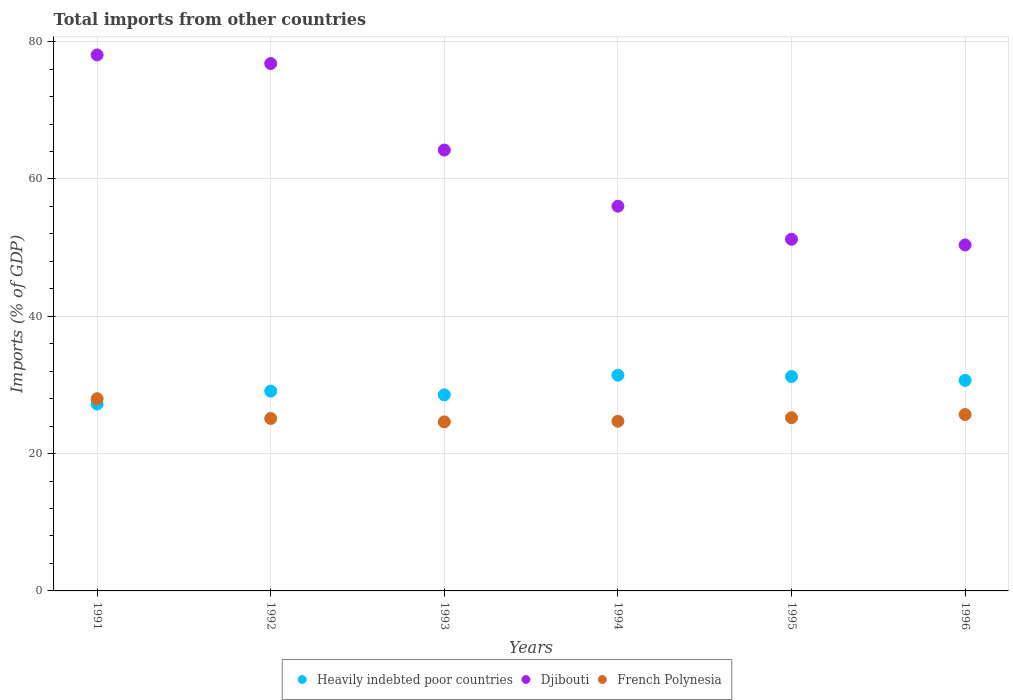Is the number of dotlines equal to the number of legend labels?
Provide a succinct answer. Yes. What is the total imports in French Polynesia in 1994?
Your answer should be compact. 24.71. Across all years, what is the maximum total imports in French Polynesia?
Your answer should be compact. 27.99. Across all years, what is the minimum total imports in Heavily indebted poor countries?
Your response must be concise. 27.21. In which year was the total imports in Heavily indebted poor countries maximum?
Your answer should be compact. 1994. In which year was the total imports in Djibouti minimum?
Your answer should be compact. 1996. What is the total total imports in Djibouti in the graph?
Your response must be concise. 376.7. What is the difference between the total imports in Heavily indebted poor countries in 1991 and that in 1993?
Offer a terse response. -1.34. What is the difference between the total imports in French Polynesia in 1991 and the total imports in Djibouti in 1996?
Your answer should be compact. -22.39. What is the average total imports in French Polynesia per year?
Make the answer very short. 25.56. In the year 1993, what is the difference between the total imports in Djibouti and total imports in French Polynesia?
Your answer should be compact. 39.59. What is the ratio of the total imports in French Polynesia in 1992 to that in 1994?
Make the answer very short. 1.02. Is the total imports in Djibouti in 1994 less than that in 1995?
Give a very brief answer. No. Is the difference between the total imports in Djibouti in 1994 and 1995 greater than the difference between the total imports in French Polynesia in 1994 and 1995?
Keep it short and to the point. Yes. What is the difference between the highest and the second highest total imports in Djibouti?
Provide a succinct answer. 1.26. What is the difference between the highest and the lowest total imports in Djibouti?
Your response must be concise. 27.68. In how many years, is the total imports in Djibouti greater than the average total imports in Djibouti taken over all years?
Offer a terse response. 3. Does the total imports in Djibouti monotonically increase over the years?
Offer a terse response. No. Is the total imports in Heavily indebted poor countries strictly greater than the total imports in Djibouti over the years?
Provide a succinct answer. No. How many years are there in the graph?
Provide a short and direct response. 6. Are the values on the major ticks of Y-axis written in scientific E-notation?
Keep it short and to the point. No. Does the graph contain grids?
Your answer should be very brief. Yes. Where does the legend appear in the graph?
Make the answer very short. Bottom center. What is the title of the graph?
Offer a very short reply. Total imports from other countries. Does "Northern Mariana Islands" appear as one of the legend labels in the graph?
Provide a succinct answer. No. What is the label or title of the X-axis?
Keep it short and to the point. Years. What is the label or title of the Y-axis?
Give a very brief answer. Imports (% of GDP). What is the Imports (% of GDP) of Heavily indebted poor countries in 1991?
Your answer should be compact. 27.21. What is the Imports (% of GDP) of Djibouti in 1991?
Provide a short and direct response. 78.06. What is the Imports (% of GDP) in French Polynesia in 1991?
Ensure brevity in your answer.  27.99. What is the Imports (% of GDP) in Heavily indebted poor countries in 1992?
Keep it short and to the point. 29.1. What is the Imports (% of GDP) of Djibouti in 1992?
Ensure brevity in your answer.  76.8. What is the Imports (% of GDP) of French Polynesia in 1992?
Make the answer very short. 25.12. What is the Imports (% of GDP) in Heavily indebted poor countries in 1993?
Give a very brief answer. 28.55. What is the Imports (% of GDP) in Djibouti in 1993?
Keep it short and to the point. 64.21. What is the Imports (% of GDP) of French Polynesia in 1993?
Make the answer very short. 24.62. What is the Imports (% of GDP) in Heavily indebted poor countries in 1994?
Provide a succinct answer. 31.42. What is the Imports (% of GDP) in Djibouti in 1994?
Provide a short and direct response. 56.03. What is the Imports (% of GDP) of French Polynesia in 1994?
Ensure brevity in your answer.  24.71. What is the Imports (% of GDP) in Heavily indebted poor countries in 1995?
Your answer should be very brief. 31.22. What is the Imports (% of GDP) in Djibouti in 1995?
Provide a short and direct response. 51.22. What is the Imports (% of GDP) in French Polynesia in 1995?
Your response must be concise. 25.23. What is the Imports (% of GDP) in Heavily indebted poor countries in 1996?
Provide a succinct answer. 30.67. What is the Imports (% of GDP) of Djibouti in 1996?
Offer a very short reply. 50.39. What is the Imports (% of GDP) of French Polynesia in 1996?
Your response must be concise. 25.69. Across all years, what is the maximum Imports (% of GDP) in Heavily indebted poor countries?
Provide a short and direct response. 31.42. Across all years, what is the maximum Imports (% of GDP) in Djibouti?
Ensure brevity in your answer.  78.06. Across all years, what is the maximum Imports (% of GDP) in French Polynesia?
Provide a short and direct response. 27.99. Across all years, what is the minimum Imports (% of GDP) of Heavily indebted poor countries?
Make the answer very short. 27.21. Across all years, what is the minimum Imports (% of GDP) of Djibouti?
Provide a succinct answer. 50.39. Across all years, what is the minimum Imports (% of GDP) in French Polynesia?
Your response must be concise. 24.62. What is the total Imports (% of GDP) of Heavily indebted poor countries in the graph?
Your answer should be compact. 178.17. What is the total Imports (% of GDP) of Djibouti in the graph?
Your answer should be compact. 376.7. What is the total Imports (% of GDP) in French Polynesia in the graph?
Offer a very short reply. 153.35. What is the difference between the Imports (% of GDP) of Heavily indebted poor countries in 1991 and that in 1992?
Give a very brief answer. -1.89. What is the difference between the Imports (% of GDP) in Djibouti in 1991 and that in 1992?
Your answer should be very brief. 1.26. What is the difference between the Imports (% of GDP) of French Polynesia in 1991 and that in 1992?
Provide a succinct answer. 2.88. What is the difference between the Imports (% of GDP) in Heavily indebted poor countries in 1991 and that in 1993?
Ensure brevity in your answer.  -1.34. What is the difference between the Imports (% of GDP) in Djibouti in 1991 and that in 1993?
Provide a short and direct response. 13.85. What is the difference between the Imports (% of GDP) of French Polynesia in 1991 and that in 1993?
Provide a succinct answer. 3.37. What is the difference between the Imports (% of GDP) of Heavily indebted poor countries in 1991 and that in 1994?
Provide a short and direct response. -4.21. What is the difference between the Imports (% of GDP) of Djibouti in 1991 and that in 1994?
Your response must be concise. 22.03. What is the difference between the Imports (% of GDP) in French Polynesia in 1991 and that in 1994?
Make the answer very short. 3.28. What is the difference between the Imports (% of GDP) of Heavily indebted poor countries in 1991 and that in 1995?
Offer a terse response. -4.01. What is the difference between the Imports (% of GDP) of Djibouti in 1991 and that in 1995?
Your answer should be very brief. 26.84. What is the difference between the Imports (% of GDP) of French Polynesia in 1991 and that in 1995?
Offer a very short reply. 2.77. What is the difference between the Imports (% of GDP) in Heavily indebted poor countries in 1991 and that in 1996?
Offer a terse response. -3.45. What is the difference between the Imports (% of GDP) in Djibouti in 1991 and that in 1996?
Ensure brevity in your answer.  27.68. What is the difference between the Imports (% of GDP) of French Polynesia in 1991 and that in 1996?
Provide a succinct answer. 2.31. What is the difference between the Imports (% of GDP) in Heavily indebted poor countries in 1992 and that in 1993?
Your answer should be very brief. 0.54. What is the difference between the Imports (% of GDP) in Djibouti in 1992 and that in 1993?
Your answer should be very brief. 12.59. What is the difference between the Imports (% of GDP) in French Polynesia in 1992 and that in 1993?
Make the answer very short. 0.5. What is the difference between the Imports (% of GDP) of Heavily indebted poor countries in 1992 and that in 1994?
Make the answer very short. -2.32. What is the difference between the Imports (% of GDP) in Djibouti in 1992 and that in 1994?
Your answer should be very brief. 20.77. What is the difference between the Imports (% of GDP) of French Polynesia in 1992 and that in 1994?
Ensure brevity in your answer.  0.4. What is the difference between the Imports (% of GDP) of Heavily indebted poor countries in 1992 and that in 1995?
Make the answer very short. -2.12. What is the difference between the Imports (% of GDP) of Djibouti in 1992 and that in 1995?
Offer a very short reply. 25.58. What is the difference between the Imports (% of GDP) in French Polynesia in 1992 and that in 1995?
Your answer should be very brief. -0.11. What is the difference between the Imports (% of GDP) of Heavily indebted poor countries in 1992 and that in 1996?
Your response must be concise. -1.57. What is the difference between the Imports (% of GDP) in Djibouti in 1992 and that in 1996?
Make the answer very short. 26.42. What is the difference between the Imports (% of GDP) in French Polynesia in 1992 and that in 1996?
Give a very brief answer. -0.57. What is the difference between the Imports (% of GDP) of Heavily indebted poor countries in 1993 and that in 1994?
Provide a succinct answer. -2.86. What is the difference between the Imports (% of GDP) in Djibouti in 1993 and that in 1994?
Make the answer very short. 8.18. What is the difference between the Imports (% of GDP) of French Polynesia in 1993 and that in 1994?
Provide a short and direct response. -0.09. What is the difference between the Imports (% of GDP) in Heavily indebted poor countries in 1993 and that in 1995?
Your answer should be very brief. -2.67. What is the difference between the Imports (% of GDP) of Djibouti in 1993 and that in 1995?
Your response must be concise. 12.99. What is the difference between the Imports (% of GDP) of French Polynesia in 1993 and that in 1995?
Offer a terse response. -0.61. What is the difference between the Imports (% of GDP) of Heavily indebted poor countries in 1993 and that in 1996?
Ensure brevity in your answer.  -2.11. What is the difference between the Imports (% of GDP) in Djibouti in 1993 and that in 1996?
Offer a very short reply. 13.82. What is the difference between the Imports (% of GDP) in French Polynesia in 1993 and that in 1996?
Offer a terse response. -1.07. What is the difference between the Imports (% of GDP) in Heavily indebted poor countries in 1994 and that in 1995?
Provide a succinct answer. 0.2. What is the difference between the Imports (% of GDP) of Djibouti in 1994 and that in 1995?
Ensure brevity in your answer.  4.81. What is the difference between the Imports (% of GDP) in French Polynesia in 1994 and that in 1995?
Your answer should be very brief. -0.51. What is the difference between the Imports (% of GDP) of Heavily indebted poor countries in 1994 and that in 1996?
Provide a short and direct response. 0.75. What is the difference between the Imports (% of GDP) in Djibouti in 1994 and that in 1996?
Your response must be concise. 5.64. What is the difference between the Imports (% of GDP) of French Polynesia in 1994 and that in 1996?
Give a very brief answer. -0.97. What is the difference between the Imports (% of GDP) in Heavily indebted poor countries in 1995 and that in 1996?
Offer a terse response. 0.56. What is the difference between the Imports (% of GDP) in Djibouti in 1995 and that in 1996?
Give a very brief answer. 0.83. What is the difference between the Imports (% of GDP) in French Polynesia in 1995 and that in 1996?
Offer a terse response. -0.46. What is the difference between the Imports (% of GDP) of Heavily indebted poor countries in 1991 and the Imports (% of GDP) of Djibouti in 1992?
Ensure brevity in your answer.  -49.59. What is the difference between the Imports (% of GDP) in Heavily indebted poor countries in 1991 and the Imports (% of GDP) in French Polynesia in 1992?
Offer a terse response. 2.1. What is the difference between the Imports (% of GDP) in Djibouti in 1991 and the Imports (% of GDP) in French Polynesia in 1992?
Your answer should be compact. 52.94. What is the difference between the Imports (% of GDP) in Heavily indebted poor countries in 1991 and the Imports (% of GDP) in Djibouti in 1993?
Make the answer very short. -36.99. What is the difference between the Imports (% of GDP) in Heavily indebted poor countries in 1991 and the Imports (% of GDP) in French Polynesia in 1993?
Offer a terse response. 2.59. What is the difference between the Imports (% of GDP) in Djibouti in 1991 and the Imports (% of GDP) in French Polynesia in 1993?
Offer a terse response. 53.44. What is the difference between the Imports (% of GDP) of Heavily indebted poor countries in 1991 and the Imports (% of GDP) of Djibouti in 1994?
Make the answer very short. -28.82. What is the difference between the Imports (% of GDP) of Heavily indebted poor countries in 1991 and the Imports (% of GDP) of French Polynesia in 1994?
Offer a very short reply. 2.5. What is the difference between the Imports (% of GDP) of Djibouti in 1991 and the Imports (% of GDP) of French Polynesia in 1994?
Your answer should be compact. 53.35. What is the difference between the Imports (% of GDP) in Heavily indebted poor countries in 1991 and the Imports (% of GDP) in Djibouti in 1995?
Your response must be concise. -24. What is the difference between the Imports (% of GDP) of Heavily indebted poor countries in 1991 and the Imports (% of GDP) of French Polynesia in 1995?
Provide a short and direct response. 1.99. What is the difference between the Imports (% of GDP) of Djibouti in 1991 and the Imports (% of GDP) of French Polynesia in 1995?
Offer a terse response. 52.83. What is the difference between the Imports (% of GDP) of Heavily indebted poor countries in 1991 and the Imports (% of GDP) of Djibouti in 1996?
Your answer should be compact. -23.17. What is the difference between the Imports (% of GDP) in Heavily indebted poor countries in 1991 and the Imports (% of GDP) in French Polynesia in 1996?
Keep it short and to the point. 1.53. What is the difference between the Imports (% of GDP) of Djibouti in 1991 and the Imports (% of GDP) of French Polynesia in 1996?
Provide a short and direct response. 52.37. What is the difference between the Imports (% of GDP) in Heavily indebted poor countries in 1992 and the Imports (% of GDP) in Djibouti in 1993?
Your response must be concise. -35.11. What is the difference between the Imports (% of GDP) in Heavily indebted poor countries in 1992 and the Imports (% of GDP) in French Polynesia in 1993?
Your answer should be very brief. 4.48. What is the difference between the Imports (% of GDP) of Djibouti in 1992 and the Imports (% of GDP) of French Polynesia in 1993?
Keep it short and to the point. 52.18. What is the difference between the Imports (% of GDP) of Heavily indebted poor countries in 1992 and the Imports (% of GDP) of Djibouti in 1994?
Your response must be concise. -26.93. What is the difference between the Imports (% of GDP) of Heavily indebted poor countries in 1992 and the Imports (% of GDP) of French Polynesia in 1994?
Offer a terse response. 4.39. What is the difference between the Imports (% of GDP) of Djibouti in 1992 and the Imports (% of GDP) of French Polynesia in 1994?
Ensure brevity in your answer.  52.09. What is the difference between the Imports (% of GDP) of Heavily indebted poor countries in 1992 and the Imports (% of GDP) of Djibouti in 1995?
Make the answer very short. -22.12. What is the difference between the Imports (% of GDP) in Heavily indebted poor countries in 1992 and the Imports (% of GDP) in French Polynesia in 1995?
Your answer should be compact. 3.87. What is the difference between the Imports (% of GDP) of Djibouti in 1992 and the Imports (% of GDP) of French Polynesia in 1995?
Your response must be concise. 51.58. What is the difference between the Imports (% of GDP) of Heavily indebted poor countries in 1992 and the Imports (% of GDP) of Djibouti in 1996?
Your answer should be compact. -21.29. What is the difference between the Imports (% of GDP) of Heavily indebted poor countries in 1992 and the Imports (% of GDP) of French Polynesia in 1996?
Provide a succinct answer. 3.41. What is the difference between the Imports (% of GDP) in Djibouti in 1992 and the Imports (% of GDP) in French Polynesia in 1996?
Ensure brevity in your answer.  51.12. What is the difference between the Imports (% of GDP) of Heavily indebted poor countries in 1993 and the Imports (% of GDP) of Djibouti in 1994?
Offer a very short reply. -27.48. What is the difference between the Imports (% of GDP) in Heavily indebted poor countries in 1993 and the Imports (% of GDP) in French Polynesia in 1994?
Your answer should be compact. 3.84. What is the difference between the Imports (% of GDP) in Djibouti in 1993 and the Imports (% of GDP) in French Polynesia in 1994?
Your answer should be very brief. 39.5. What is the difference between the Imports (% of GDP) in Heavily indebted poor countries in 1993 and the Imports (% of GDP) in Djibouti in 1995?
Offer a terse response. -22.66. What is the difference between the Imports (% of GDP) in Heavily indebted poor countries in 1993 and the Imports (% of GDP) in French Polynesia in 1995?
Ensure brevity in your answer.  3.33. What is the difference between the Imports (% of GDP) in Djibouti in 1993 and the Imports (% of GDP) in French Polynesia in 1995?
Provide a short and direct response. 38.98. What is the difference between the Imports (% of GDP) in Heavily indebted poor countries in 1993 and the Imports (% of GDP) in Djibouti in 1996?
Ensure brevity in your answer.  -21.83. What is the difference between the Imports (% of GDP) in Heavily indebted poor countries in 1993 and the Imports (% of GDP) in French Polynesia in 1996?
Provide a short and direct response. 2.87. What is the difference between the Imports (% of GDP) in Djibouti in 1993 and the Imports (% of GDP) in French Polynesia in 1996?
Offer a terse response. 38.52. What is the difference between the Imports (% of GDP) of Heavily indebted poor countries in 1994 and the Imports (% of GDP) of Djibouti in 1995?
Your response must be concise. -19.8. What is the difference between the Imports (% of GDP) of Heavily indebted poor countries in 1994 and the Imports (% of GDP) of French Polynesia in 1995?
Provide a short and direct response. 6.19. What is the difference between the Imports (% of GDP) in Djibouti in 1994 and the Imports (% of GDP) in French Polynesia in 1995?
Ensure brevity in your answer.  30.8. What is the difference between the Imports (% of GDP) in Heavily indebted poor countries in 1994 and the Imports (% of GDP) in Djibouti in 1996?
Provide a short and direct response. -18.97. What is the difference between the Imports (% of GDP) of Heavily indebted poor countries in 1994 and the Imports (% of GDP) of French Polynesia in 1996?
Your response must be concise. 5.73. What is the difference between the Imports (% of GDP) in Djibouti in 1994 and the Imports (% of GDP) in French Polynesia in 1996?
Keep it short and to the point. 30.34. What is the difference between the Imports (% of GDP) of Heavily indebted poor countries in 1995 and the Imports (% of GDP) of Djibouti in 1996?
Provide a succinct answer. -19.16. What is the difference between the Imports (% of GDP) in Heavily indebted poor countries in 1995 and the Imports (% of GDP) in French Polynesia in 1996?
Your answer should be very brief. 5.53. What is the difference between the Imports (% of GDP) of Djibouti in 1995 and the Imports (% of GDP) of French Polynesia in 1996?
Your answer should be very brief. 25.53. What is the average Imports (% of GDP) in Heavily indebted poor countries per year?
Make the answer very short. 29.7. What is the average Imports (% of GDP) of Djibouti per year?
Provide a short and direct response. 62.78. What is the average Imports (% of GDP) of French Polynesia per year?
Your response must be concise. 25.56. In the year 1991, what is the difference between the Imports (% of GDP) of Heavily indebted poor countries and Imports (% of GDP) of Djibouti?
Keep it short and to the point. -50.85. In the year 1991, what is the difference between the Imports (% of GDP) in Heavily indebted poor countries and Imports (% of GDP) in French Polynesia?
Provide a succinct answer. -0.78. In the year 1991, what is the difference between the Imports (% of GDP) of Djibouti and Imports (% of GDP) of French Polynesia?
Offer a very short reply. 50.07. In the year 1992, what is the difference between the Imports (% of GDP) in Heavily indebted poor countries and Imports (% of GDP) in Djibouti?
Give a very brief answer. -47.7. In the year 1992, what is the difference between the Imports (% of GDP) of Heavily indebted poor countries and Imports (% of GDP) of French Polynesia?
Provide a succinct answer. 3.98. In the year 1992, what is the difference between the Imports (% of GDP) of Djibouti and Imports (% of GDP) of French Polynesia?
Provide a succinct answer. 51.69. In the year 1993, what is the difference between the Imports (% of GDP) of Heavily indebted poor countries and Imports (% of GDP) of Djibouti?
Ensure brevity in your answer.  -35.65. In the year 1993, what is the difference between the Imports (% of GDP) in Heavily indebted poor countries and Imports (% of GDP) in French Polynesia?
Provide a succinct answer. 3.94. In the year 1993, what is the difference between the Imports (% of GDP) in Djibouti and Imports (% of GDP) in French Polynesia?
Your answer should be compact. 39.59. In the year 1994, what is the difference between the Imports (% of GDP) in Heavily indebted poor countries and Imports (% of GDP) in Djibouti?
Offer a very short reply. -24.61. In the year 1994, what is the difference between the Imports (% of GDP) in Heavily indebted poor countries and Imports (% of GDP) in French Polynesia?
Provide a short and direct response. 6.71. In the year 1994, what is the difference between the Imports (% of GDP) of Djibouti and Imports (% of GDP) of French Polynesia?
Give a very brief answer. 31.32. In the year 1995, what is the difference between the Imports (% of GDP) of Heavily indebted poor countries and Imports (% of GDP) of Djibouti?
Provide a short and direct response. -20. In the year 1995, what is the difference between the Imports (% of GDP) of Heavily indebted poor countries and Imports (% of GDP) of French Polynesia?
Provide a short and direct response. 5.99. In the year 1995, what is the difference between the Imports (% of GDP) of Djibouti and Imports (% of GDP) of French Polynesia?
Your response must be concise. 25.99. In the year 1996, what is the difference between the Imports (% of GDP) in Heavily indebted poor countries and Imports (% of GDP) in Djibouti?
Your answer should be compact. -19.72. In the year 1996, what is the difference between the Imports (% of GDP) of Heavily indebted poor countries and Imports (% of GDP) of French Polynesia?
Provide a short and direct response. 4.98. In the year 1996, what is the difference between the Imports (% of GDP) in Djibouti and Imports (% of GDP) in French Polynesia?
Offer a very short reply. 24.7. What is the ratio of the Imports (% of GDP) of Heavily indebted poor countries in 1991 to that in 1992?
Provide a short and direct response. 0.94. What is the ratio of the Imports (% of GDP) in Djibouti in 1991 to that in 1992?
Your answer should be very brief. 1.02. What is the ratio of the Imports (% of GDP) of French Polynesia in 1991 to that in 1992?
Your response must be concise. 1.11. What is the ratio of the Imports (% of GDP) in Heavily indebted poor countries in 1991 to that in 1993?
Make the answer very short. 0.95. What is the ratio of the Imports (% of GDP) in Djibouti in 1991 to that in 1993?
Your response must be concise. 1.22. What is the ratio of the Imports (% of GDP) in French Polynesia in 1991 to that in 1993?
Provide a short and direct response. 1.14. What is the ratio of the Imports (% of GDP) of Heavily indebted poor countries in 1991 to that in 1994?
Offer a terse response. 0.87. What is the ratio of the Imports (% of GDP) in Djibouti in 1991 to that in 1994?
Provide a short and direct response. 1.39. What is the ratio of the Imports (% of GDP) of French Polynesia in 1991 to that in 1994?
Keep it short and to the point. 1.13. What is the ratio of the Imports (% of GDP) of Heavily indebted poor countries in 1991 to that in 1995?
Keep it short and to the point. 0.87. What is the ratio of the Imports (% of GDP) of Djibouti in 1991 to that in 1995?
Provide a succinct answer. 1.52. What is the ratio of the Imports (% of GDP) of French Polynesia in 1991 to that in 1995?
Ensure brevity in your answer.  1.11. What is the ratio of the Imports (% of GDP) of Heavily indebted poor countries in 1991 to that in 1996?
Provide a succinct answer. 0.89. What is the ratio of the Imports (% of GDP) in Djibouti in 1991 to that in 1996?
Your response must be concise. 1.55. What is the ratio of the Imports (% of GDP) of French Polynesia in 1991 to that in 1996?
Your answer should be compact. 1.09. What is the ratio of the Imports (% of GDP) of Heavily indebted poor countries in 1992 to that in 1993?
Keep it short and to the point. 1.02. What is the ratio of the Imports (% of GDP) of Djibouti in 1992 to that in 1993?
Ensure brevity in your answer.  1.2. What is the ratio of the Imports (% of GDP) of French Polynesia in 1992 to that in 1993?
Provide a succinct answer. 1.02. What is the ratio of the Imports (% of GDP) of Heavily indebted poor countries in 1992 to that in 1994?
Your answer should be compact. 0.93. What is the ratio of the Imports (% of GDP) in Djibouti in 1992 to that in 1994?
Your answer should be compact. 1.37. What is the ratio of the Imports (% of GDP) of French Polynesia in 1992 to that in 1994?
Your response must be concise. 1.02. What is the ratio of the Imports (% of GDP) in Heavily indebted poor countries in 1992 to that in 1995?
Provide a succinct answer. 0.93. What is the ratio of the Imports (% of GDP) of Djibouti in 1992 to that in 1995?
Offer a very short reply. 1.5. What is the ratio of the Imports (% of GDP) in Heavily indebted poor countries in 1992 to that in 1996?
Ensure brevity in your answer.  0.95. What is the ratio of the Imports (% of GDP) of Djibouti in 1992 to that in 1996?
Offer a very short reply. 1.52. What is the ratio of the Imports (% of GDP) in French Polynesia in 1992 to that in 1996?
Your response must be concise. 0.98. What is the ratio of the Imports (% of GDP) in Heavily indebted poor countries in 1993 to that in 1994?
Your answer should be very brief. 0.91. What is the ratio of the Imports (% of GDP) in Djibouti in 1993 to that in 1994?
Provide a succinct answer. 1.15. What is the ratio of the Imports (% of GDP) of French Polynesia in 1993 to that in 1994?
Provide a short and direct response. 1. What is the ratio of the Imports (% of GDP) of Heavily indebted poor countries in 1993 to that in 1995?
Keep it short and to the point. 0.91. What is the ratio of the Imports (% of GDP) in Djibouti in 1993 to that in 1995?
Offer a terse response. 1.25. What is the ratio of the Imports (% of GDP) of French Polynesia in 1993 to that in 1995?
Your response must be concise. 0.98. What is the ratio of the Imports (% of GDP) of Heavily indebted poor countries in 1993 to that in 1996?
Offer a terse response. 0.93. What is the ratio of the Imports (% of GDP) of Djibouti in 1993 to that in 1996?
Keep it short and to the point. 1.27. What is the ratio of the Imports (% of GDP) of French Polynesia in 1993 to that in 1996?
Make the answer very short. 0.96. What is the ratio of the Imports (% of GDP) in Djibouti in 1994 to that in 1995?
Provide a short and direct response. 1.09. What is the ratio of the Imports (% of GDP) in French Polynesia in 1994 to that in 1995?
Offer a terse response. 0.98. What is the ratio of the Imports (% of GDP) of Heavily indebted poor countries in 1994 to that in 1996?
Your answer should be compact. 1.02. What is the ratio of the Imports (% of GDP) in Djibouti in 1994 to that in 1996?
Give a very brief answer. 1.11. What is the ratio of the Imports (% of GDP) of French Polynesia in 1994 to that in 1996?
Your answer should be compact. 0.96. What is the ratio of the Imports (% of GDP) of Heavily indebted poor countries in 1995 to that in 1996?
Provide a succinct answer. 1.02. What is the ratio of the Imports (% of GDP) of Djibouti in 1995 to that in 1996?
Ensure brevity in your answer.  1.02. What is the ratio of the Imports (% of GDP) of French Polynesia in 1995 to that in 1996?
Your answer should be very brief. 0.98. What is the difference between the highest and the second highest Imports (% of GDP) in Heavily indebted poor countries?
Provide a succinct answer. 0.2. What is the difference between the highest and the second highest Imports (% of GDP) of Djibouti?
Offer a terse response. 1.26. What is the difference between the highest and the second highest Imports (% of GDP) in French Polynesia?
Make the answer very short. 2.31. What is the difference between the highest and the lowest Imports (% of GDP) of Heavily indebted poor countries?
Your answer should be compact. 4.21. What is the difference between the highest and the lowest Imports (% of GDP) in Djibouti?
Keep it short and to the point. 27.68. What is the difference between the highest and the lowest Imports (% of GDP) of French Polynesia?
Ensure brevity in your answer.  3.37. 